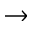<formula> <loc_0><loc_0><loc_500><loc_500>\to</formula> 